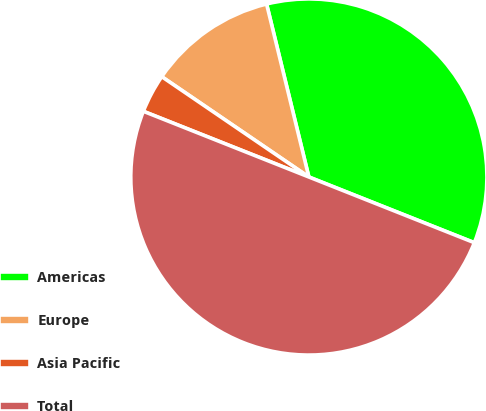Convert chart to OTSL. <chart><loc_0><loc_0><loc_500><loc_500><pie_chart><fcel>Americas<fcel>Europe<fcel>Asia Pacific<fcel>Total<nl><fcel>34.83%<fcel>11.66%<fcel>3.51%<fcel>50.0%<nl></chart> 